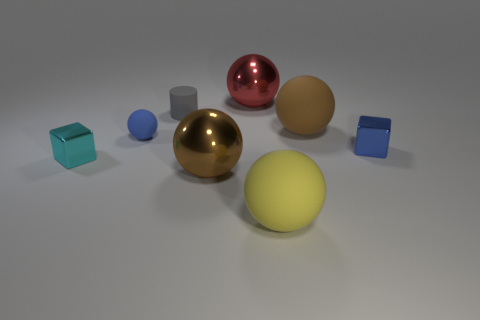Subtract all cyan spheres. Subtract all gray cylinders. How many spheres are left? 5 Add 1 large green rubber things. How many objects exist? 9 Subtract all cubes. How many objects are left? 6 Subtract 0 yellow cylinders. How many objects are left? 8 Subtract all cylinders. Subtract all small shiny things. How many objects are left? 5 Add 2 tiny blue rubber things. How many tiny blue rubber things are left? 3 Add 2 tiny cyan objects. How many tiny cyan objects exist? 3 